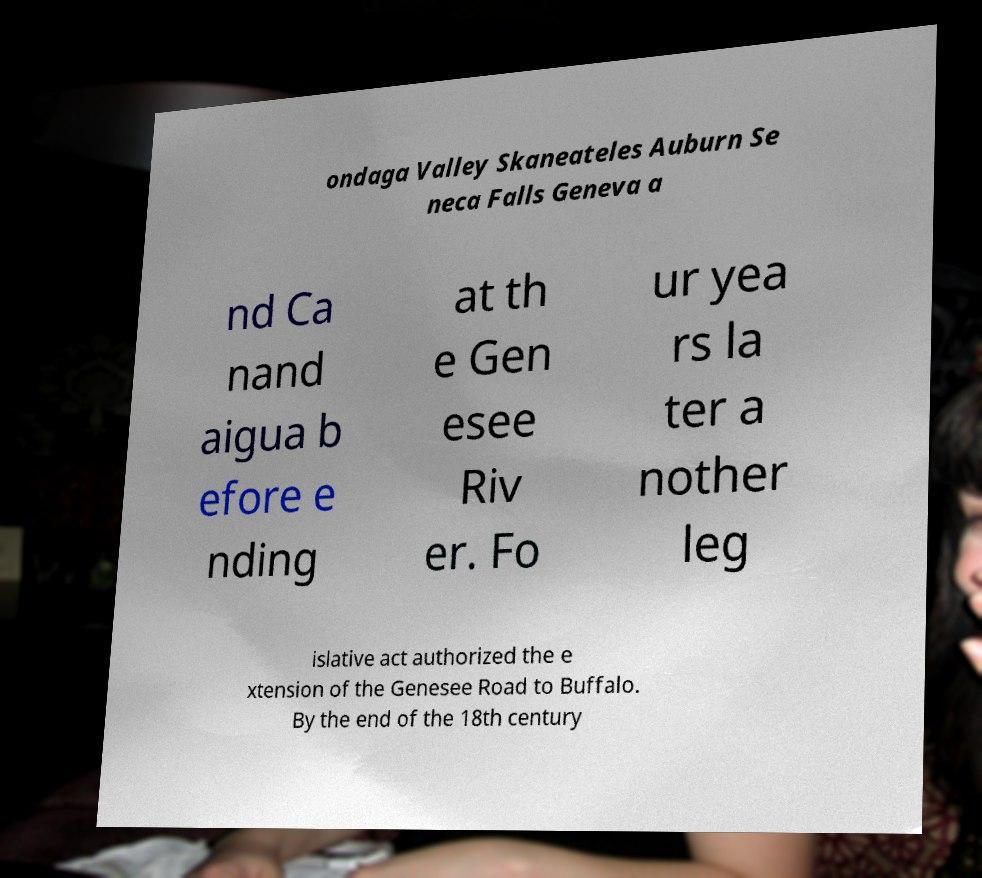Please read and relay the text visible in this image. What does it say? ondaga Valley Skaneateles Auburn Se neca Falls Geneva a nd Ca nand aigua b efore e nding at th e Gen esee Riv er. Fo ur yea rs la ter a nother leg islative act authorized the e xtension of the Genesee Road to Buffalo. By the end of the 18th century 